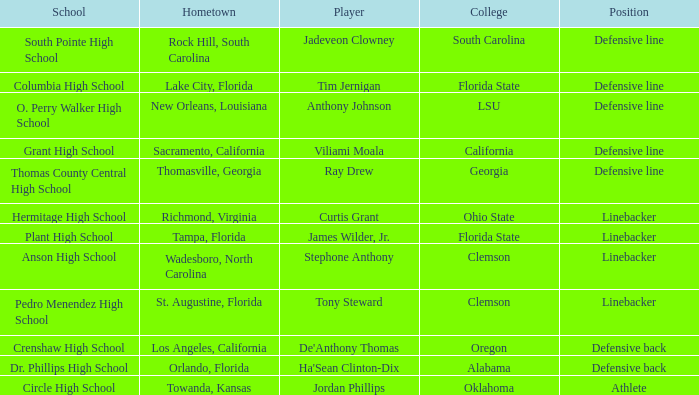Which college is Jordan Phillips playing for? Oklahoma. 